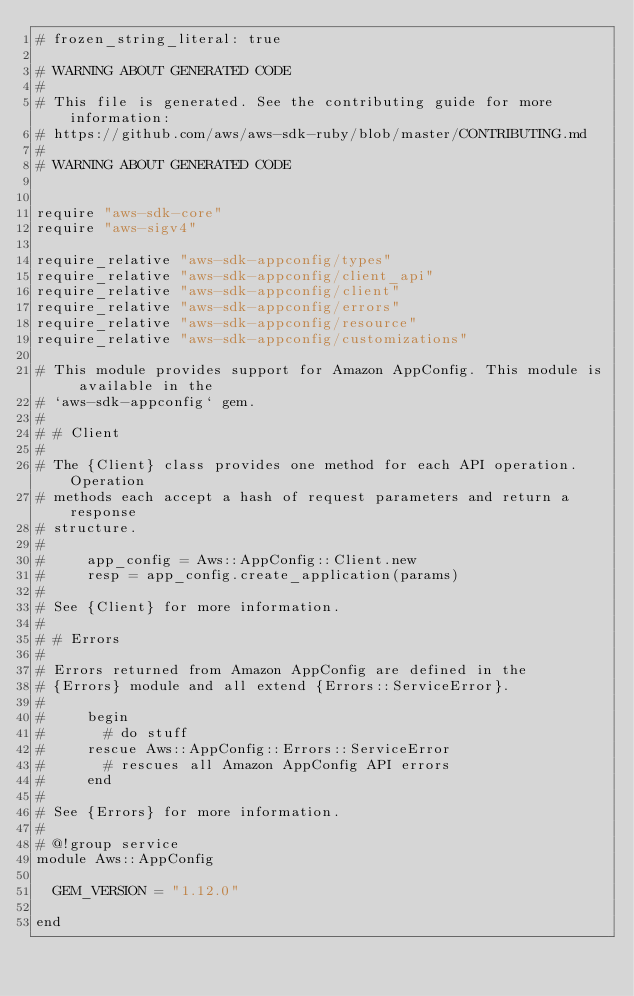Convert code to text. <code><loc_0><loc_0><loc_500><loc_500><_Crystal_># frozen_string_literal: true

# WARNING ABOUT GENERATED CODE
#
# This file is generated. See the contributing guide for more information:
# https://github.com/aws/aws-sdk-ruby/blob/master/CONTRIBUTING.md
#
# WARNING ABOUT GENERATED CODE


require "aws-sdk-core"
require "aws-sigv4"

require_relative "aws-sdk-appconfig/types"
require_relative "aws-sdk-appconfig/client_api"
require_relative "aws-sdk-appconfig/client"
require_relative "aws-sdk-appconfig/errors"
require_relative "aws-sdk-appconfig/resource"
require_relative "aws-sdk-appconfig/customizations"

# This module provides support for Amazon AppConfig. This module is available in the
# `aws-sdk-appconfig` gem.
#
# # Client
#
# The {Client} class provides one method for each API operation. Operation
# methods each accept a hash of request parameters and return a response
# structure.
#
#     app_config = Aws::AppConfig::Client.new
#     resp = app_config.create_application(params)
#
# See {Client} for more information.
#
# # Errors
#
# Errors returned from Amazon AppConfig are defined in the
# {Errors} module and all extend {Errors::ServiceError}.
#
#     begin
#       # do stuff
#     rescue Aws::AppConfig::Errors::ServiceError
#       # rescues all Amazon AppConfig API errors
#     end
#
# See {Errors} for more information.
#
# @!group service
module Aws::AppConfig

  GEM_VERSION = "1.12.0"

end
</code> 